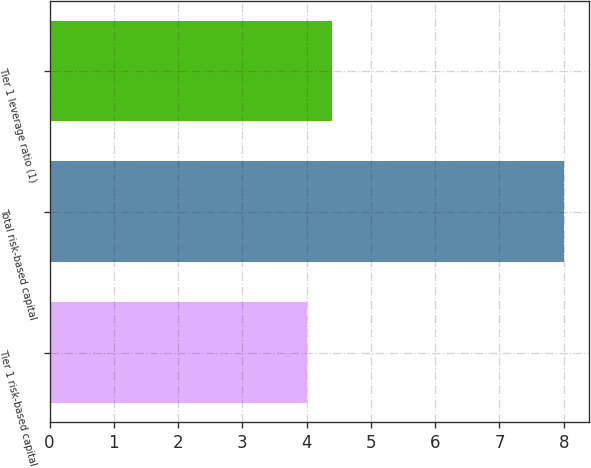<chart> <loc_0><loc_0><loc_500><loc_500><bar_chart><fcel>Tier 1 risk-based capital<fcel>Total risk-based capital<fcel>Tier 1 leverage ratio (1)<nl><fcel>4<fcel>8<fcel>4.4<nl></chart> 